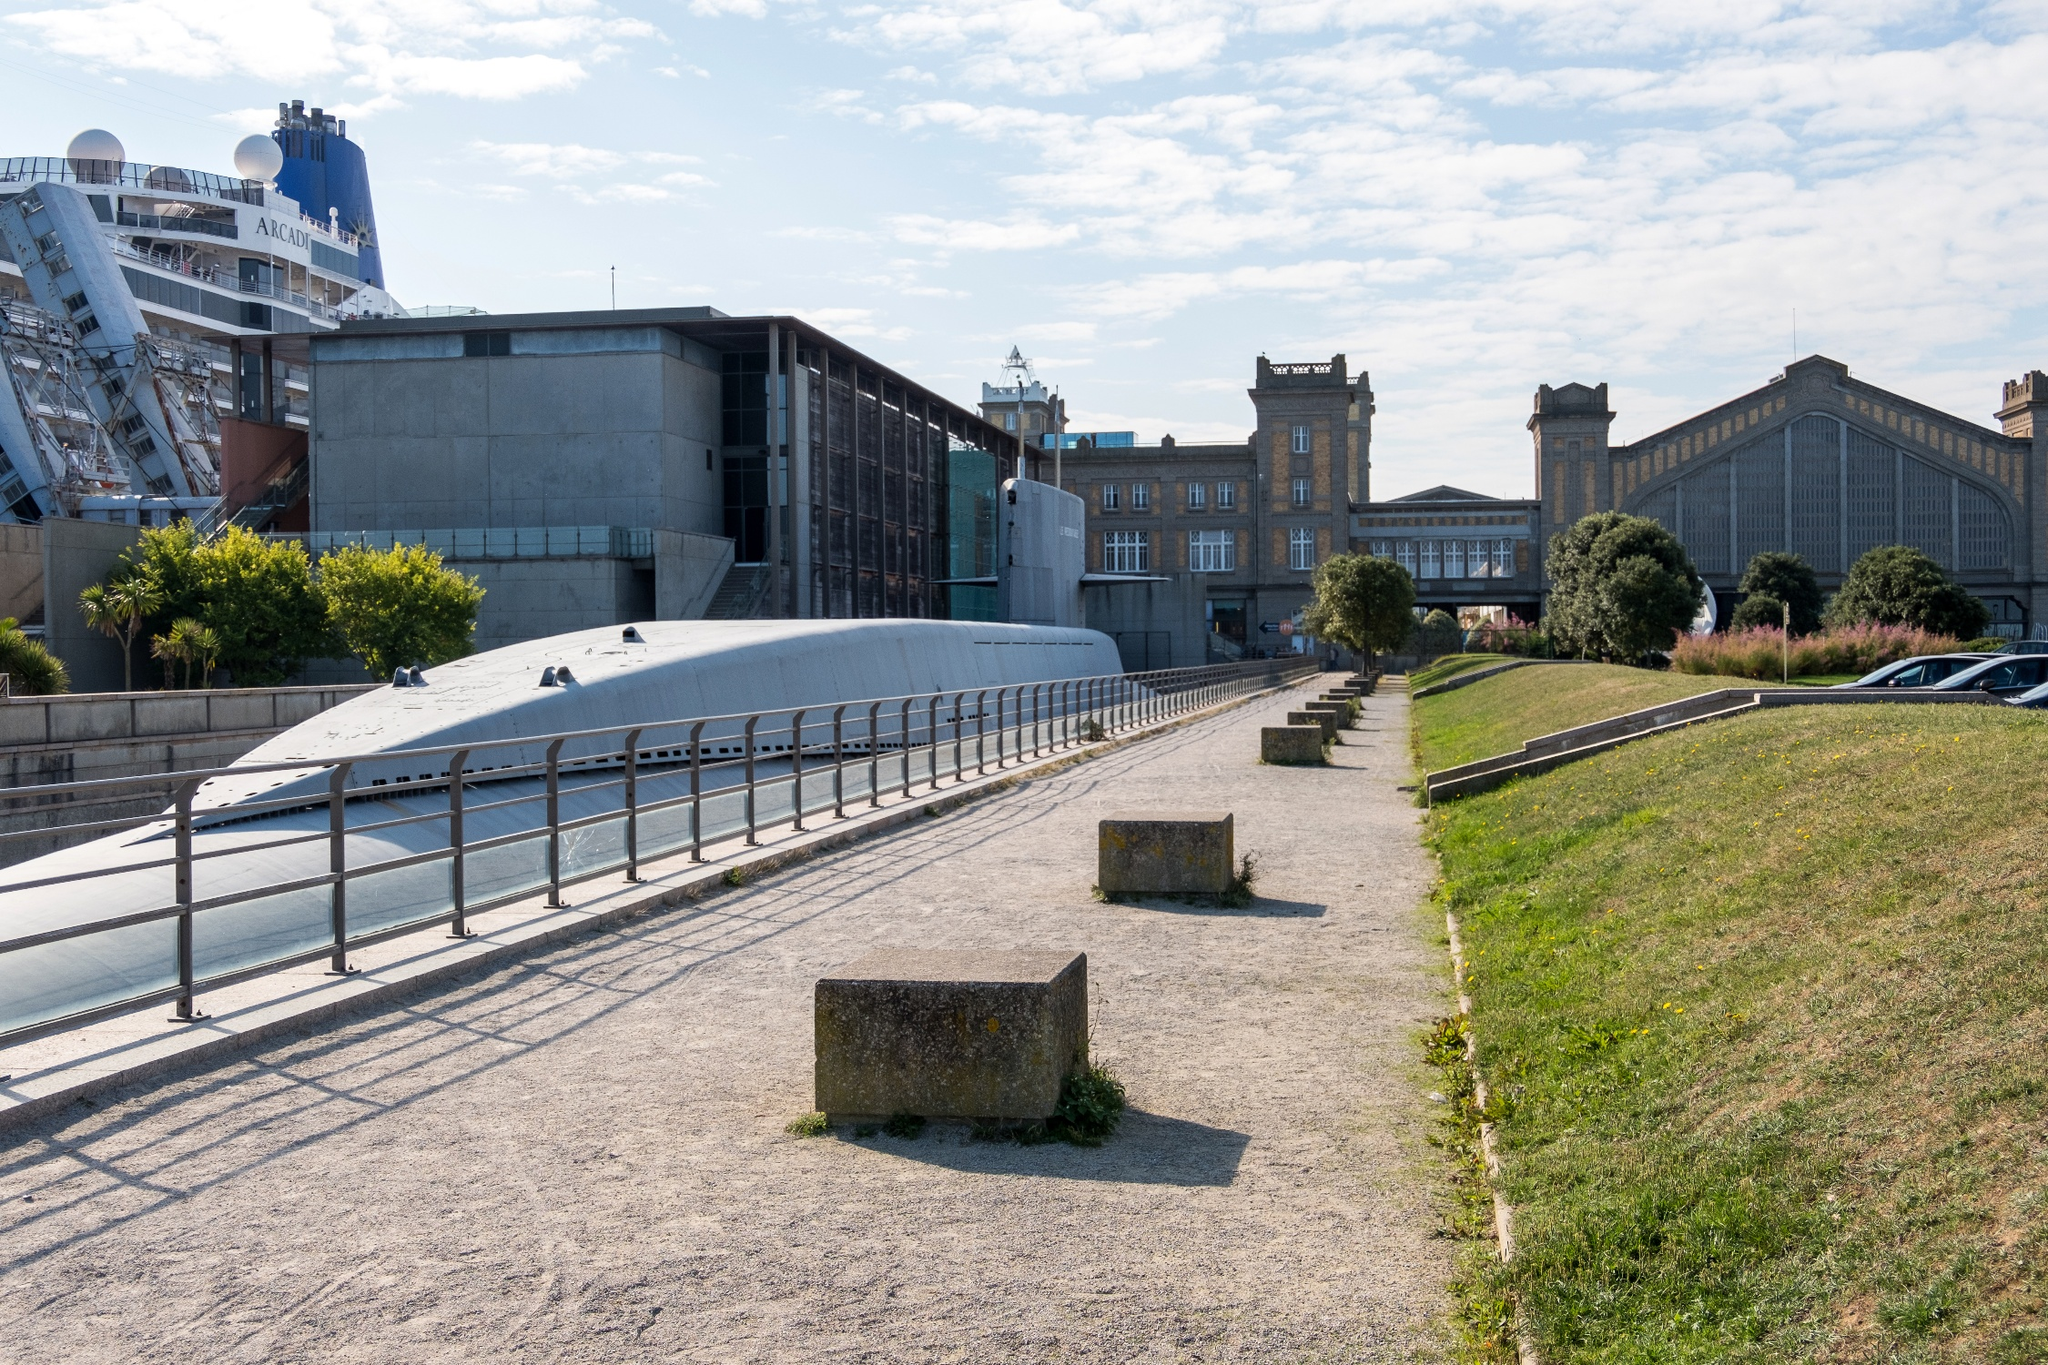Imagine a creative story involving the figures in the buildings or ships seen in the photo. Beneath the calm blue sky, there lies a hidden intrigue among the figures within the buildings and ships of Cherbourg. The grand industrial building houses a secret society of historians and inventors dedicated to preserving the maritime history while pushing the bounds of modern technology. Their headquarters, hidden from plain sight, looks out over the port where a docked cruise ship serves as a cover for their operations. The ship’s staff are not just crewmembers but also undercover agents, relaying secret codes hidden in daily broadcasts. In this city where old meets new, an underground network ensures Cherbourg remains a pivotal site of global maritime influence, shrouded in mystery and bound by a legacy of innovation. 